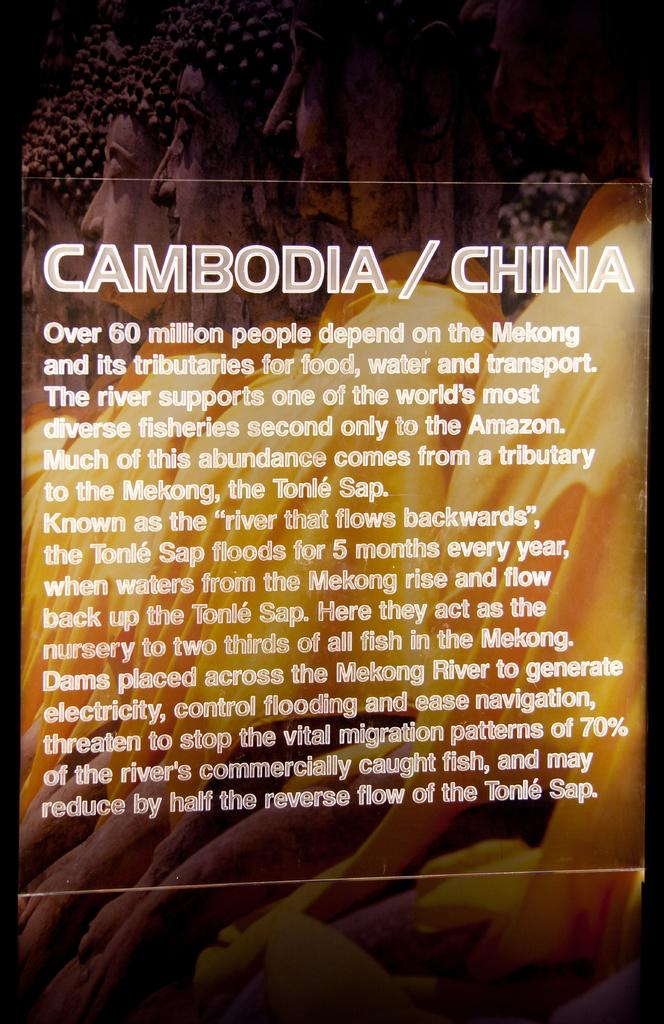Provide a one-sentence caption for the provided image. A description for how something relates to Cambodia and China. 